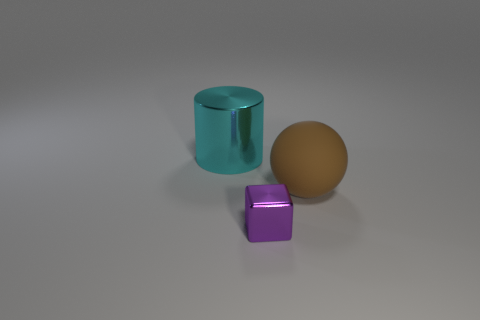How many yellow balls are there?
Keep it short and to the point. 0. Does the large thing that is on the right side of the purple metal block have the same material as the object that is left of the purple object?
Offer a terse response. No. What is the size of the cyan object that is made of the same material as the tiny purple object?
Provide a succinct answer. Large. The thing that is on the left side of the metal cube has what shape?
Give a very brief answer. Cylinder. There is a big object that is to the left of the tiny object; is it the same color as the object in front of the matte object?
Provide a succinct answer. No. Are any large metal things visible?
Provide a short and direct response. Yes. There is a metal object on the left side of the thing that is in front of the big thing that is to the right of the purple metallic thing; what is its shape?
Give a very brief answer. Cylinder. What number of metallic cylinders are behind the big brown rubber thing?
Give a very brief answer. 1. Does the large object that is in front of the large cylinder have the same material as the big cylinder?
Offer a very short reply. No. What number of other things are there of the same shape as the big cyan shiny thing?
Your answer should be very brief. 0. 